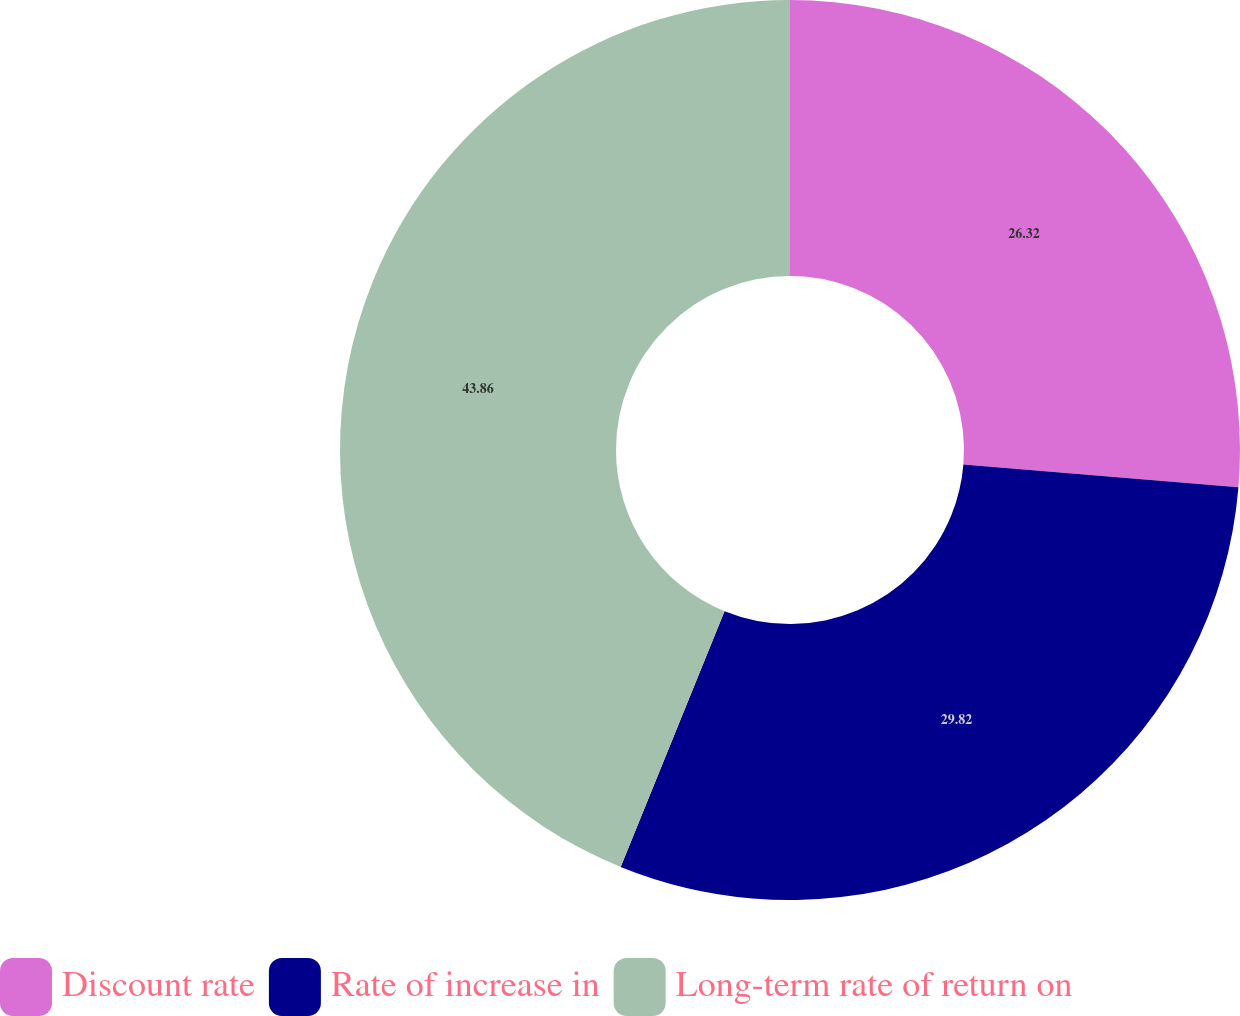Convert chart to OTSL. <chart><loc_0><loc_0><loc_500><loc_500><pie_chart><fcel>Discount rate<fcel>Rate of increase in<fcel>Long-term rate of return on<nl><fcel>26.32%<fcel>29.82%<fcel>43.86%<nl></chart> 